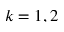<formula> <loc_0><loc_0><loc_500><loc_500>k = 1 , 2</formula> 